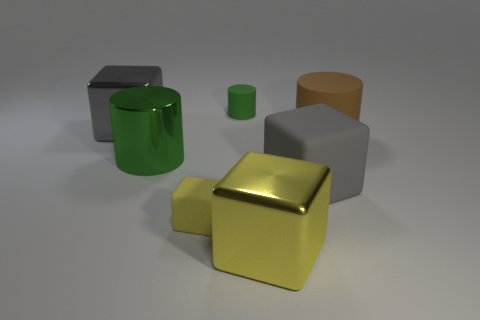There is a green thing to the right of the metal cylinder; how many small objects are in front of it?
Provide a succinct answer. 1. How many other objects are there of the same shape as the gray matte object?
Keep it short and to the point. 3. There is a tiny thing that is the same color as the metal cylinder; what is it made of?
Your answer should be compact. Rubber. How many other metallic blocks have the same color as the small cube?
Your answer should be very brief. 1. There is a big block that is made of the same material as the small yellow object; what is its color?
Your answer should be compact. Gray. Is there a blue ball that has the same size as the gray metal cube?
Your response must be concise. No. Are there more green matte cylinders in front of the green matte cylinder than big gray metallic things that are left of the brown rubber object?
Your answer should be very brief. No. Is the material of the big gray object in front of the large metallic cylinder the same as the big cylinder that is on the right side of the small green cylinder?
Ensure brevity in your answer.  Yes. What shape is the green metallic object that is the same size as the brown rubber object?
Your answer should be very brief. Cylinder. Is there another green metal thing that has the same shape as the tiny green object?
Make the answer very short. Yes. 